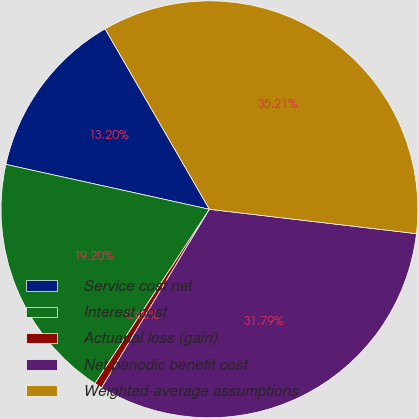Convert chart to OTSL. <chart><loc_0><loc_0><loc_500><loc_500><pie_chart><fcel>Service cost net<fcel>Interest cost<fcel>Actuarial loss (gain)<fcel>Net periodic benefit cost<fcel>Weighted-average assumptions<nl><fcel>13.2%<fcel>19.2%<fcel>0.6%<fcel>31.79%<fcel>35.21%<nl></chart> 